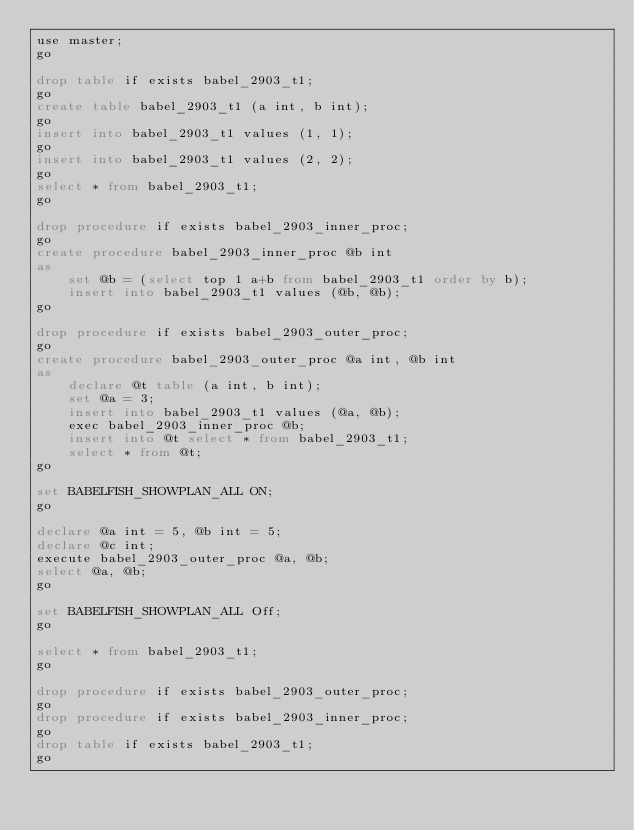<code> <loc_0><loc_0><loc_500><loc_500><_SQL_>use master;
go

drop table if exists babel_2903_t1;
go
create table babel_2903_t1 (a int, b int);
go
insert into babel_2903_t1 values (1, 1);
go
insert into babel_2903_t1 values (2, 2);
go
select * from babel_2903_t1;
go

drop procedure if exists babel_2903_inner_proc;
go
create procedure babel_2903_inner_proc @b int
as
    set @b = (select top 1 a+b from babel_2903_t1 order by b);
    insert into babel_2903_t1 values (@b, @b);
go

drop procedure if exists babel_2903_outer_proc;
go
create procedure babel_2903_outer_proc @a int, @b int
as
    declare @t table (a int, b int);
    set @a = 3;
    insert into babel_2903_t1 values (@a, @b);
    exec babel_2903_inner_proc @b;
    insert into @t select * from babel_2903_t1;
    select * from @t;
go

set BABELFISH_SHOWPLAN_ALL ON;
go

declare @a int = 5, @b int = 5;
declare @c int;
execute babel_2903_outer_proc @a, @b;
select @a, @b;
go

set BABELFISH_SHOWPLAN_ALL Off;
go

select * from babel_2903_t1;
go

drop procedure if exists babel_2903_outer_proc;
go
drop procedure if exists babel_2903_inner_proc;
go
drop table if exists babel_2903_t1;
go
</code> 